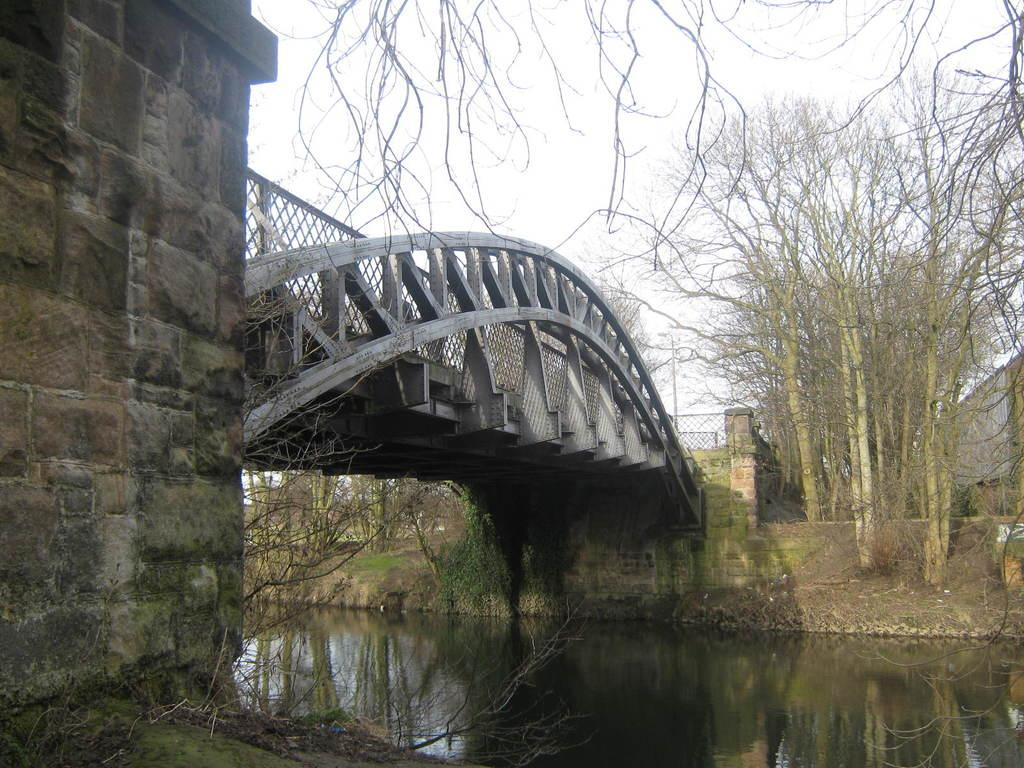What type of vegetation can be seen in the image? There are trees in the image. What structure is present in the image? There is a bridge in the image. What natural element is visible in the image? There is water visible in the image. How would you describe the sky in the image? The sky appears to be cloudy in the image. What is located on the right side of the image? There is a wall on the right side of the image. How many apples are hanging from the trees in the image? There are no apples visible in the image; only trees are present. What type of school can be seen in the image? There is no school present in the image. Can you spot an ant crawling on the bridge in the image? There is no ant visible in the image. 